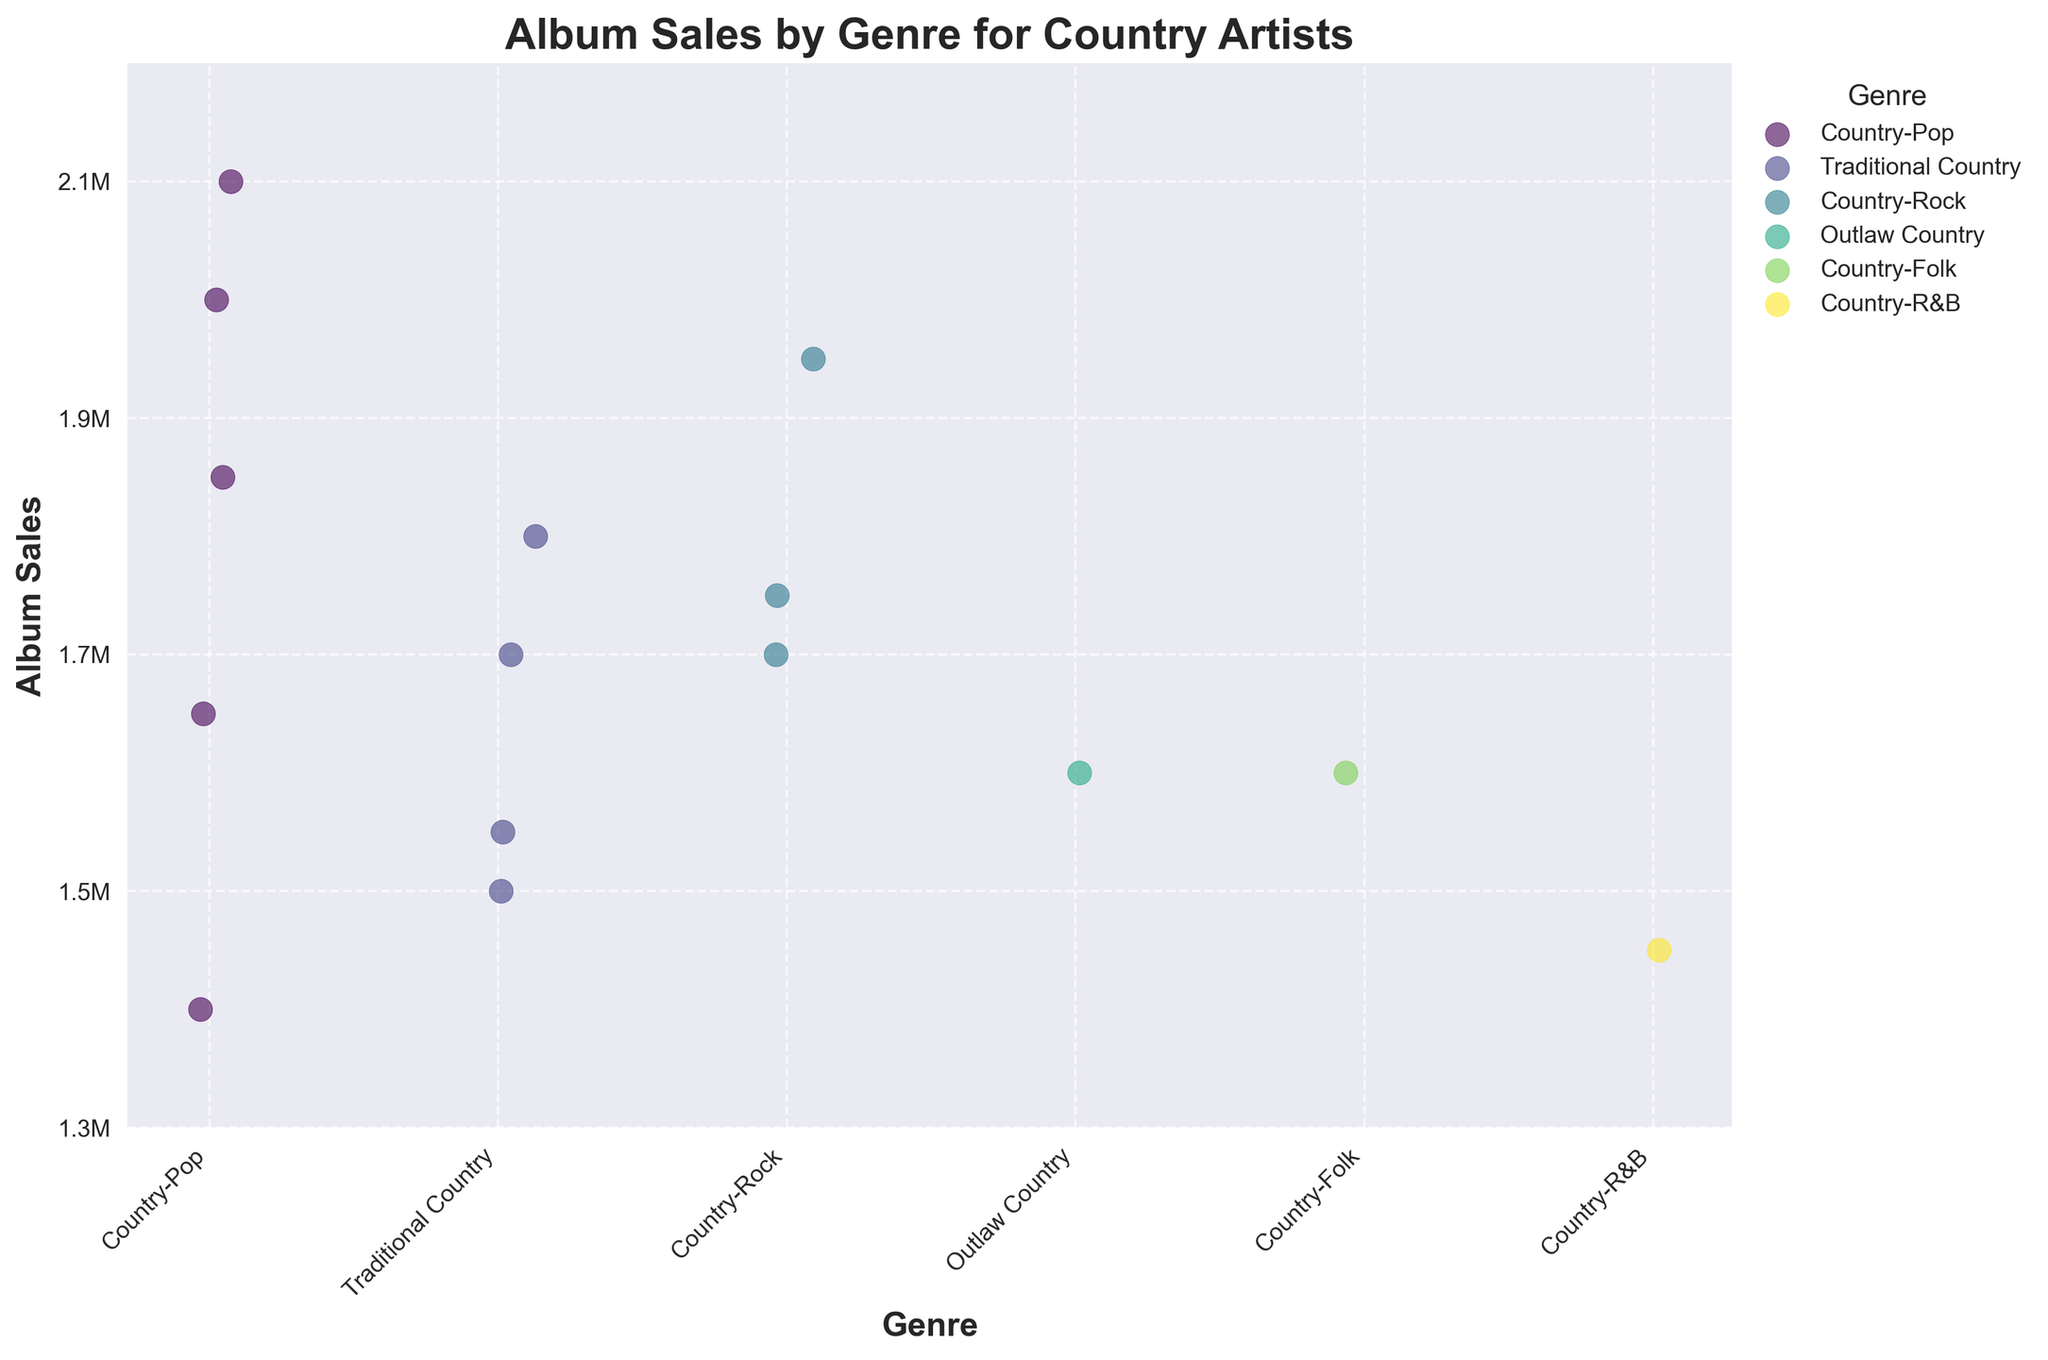What's the title of the plot? The title is written at the top of the plot, and it is "Album Sales by Genre for Country Artists."
Answer: Album Sales by Genre for Country Artists What's the range of album sales presented on the y-axis? The range of the y-axis is displayed with tick marks. It begins at 1.3 million and ends at 2.2 million.
Answer: 1.3M to 2.2M How many genres are represented in the plot? By counting the distinct tick labels on the x-axis representing different genres, we can identify the number of unique genres.
Answer: 6 genres What's the highest album sales value among the artists? The highest point on the y-axis represents the highest album sales. Referring to the maximum value within the maximum range of 2.2 million.
Answer: 2.1M Which genre has the lowest album sales point? By visually inspecting the plot and identifying the lowest point on the y-axis, we can observe that the "Country-R&B" genre has sales marked at approximately 1.45 million.
Answer: Country-R&B Which genre appears to have the most data points clustered around higher sales figures? By examining the dispersion and clustering of points, it's noticeable that “Country-Pop” has multiple points clustered near the upper range of sales.
Answer: Country-Pop What’s the album sales difference between the highest and lowest points across genres? The highest value is 2.1 million, and the lowest value is 1.45 million. Subtracting these yields 2.1M - 1.45M = 0.65M.
Answer: 0.65M What's the sales range for the "Traditional Country" genre? Look at the highest and lowest points for "Traditional Country." The highest is 1.8M, and the lowest is 1.5M. So the range is 1.8M - 1.5M = 0.3M.
Answer: 0.3M Which genre artist has the highest album sales, and what are the sales figures? By looking at the highest value in the plot and checking the corresponding genre label, "Taylor Swift" from "Country-Pop" has sales of 2.1M.
Answer: Taylor Swift, Country-Pop, 2.1M 